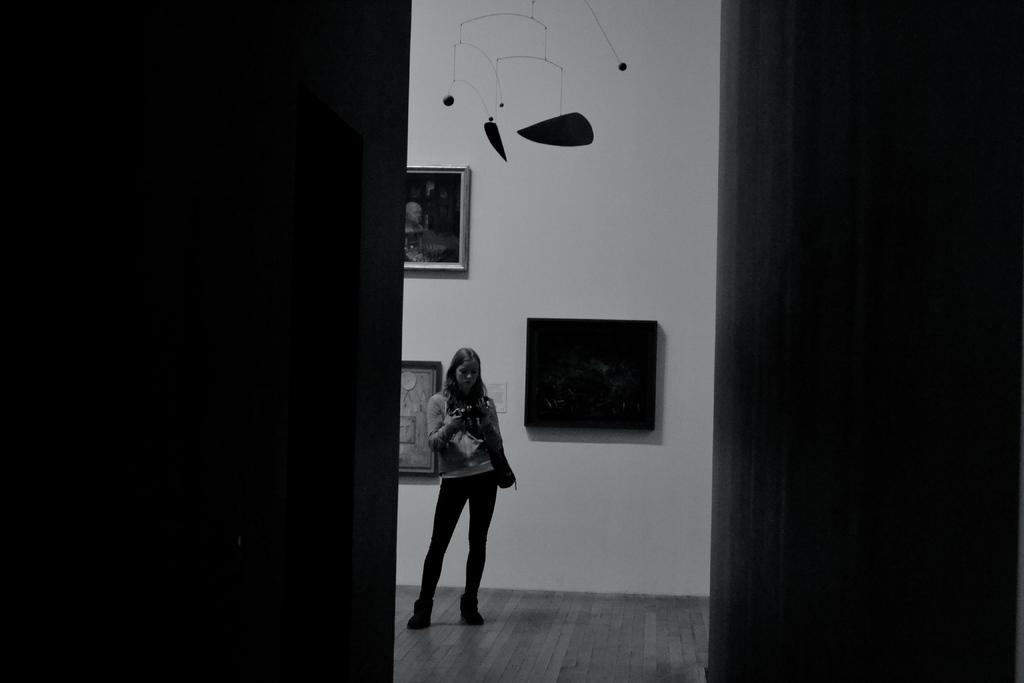What is the color scheme of the image? The image is black and white. Can you describe the person in the image? There is a person in the image. What is the person holding in the image? The person is holding an object. What can be seen on the wall in the image? There is a wall with photo frames and some art in the image. What is visible on the ground in the image? The ground is visible in the image. What type of doctor is depicted in the image? There is no doctor present in the image. What is the temper of the person in the image? The image does not provide any information about the person's temper. 